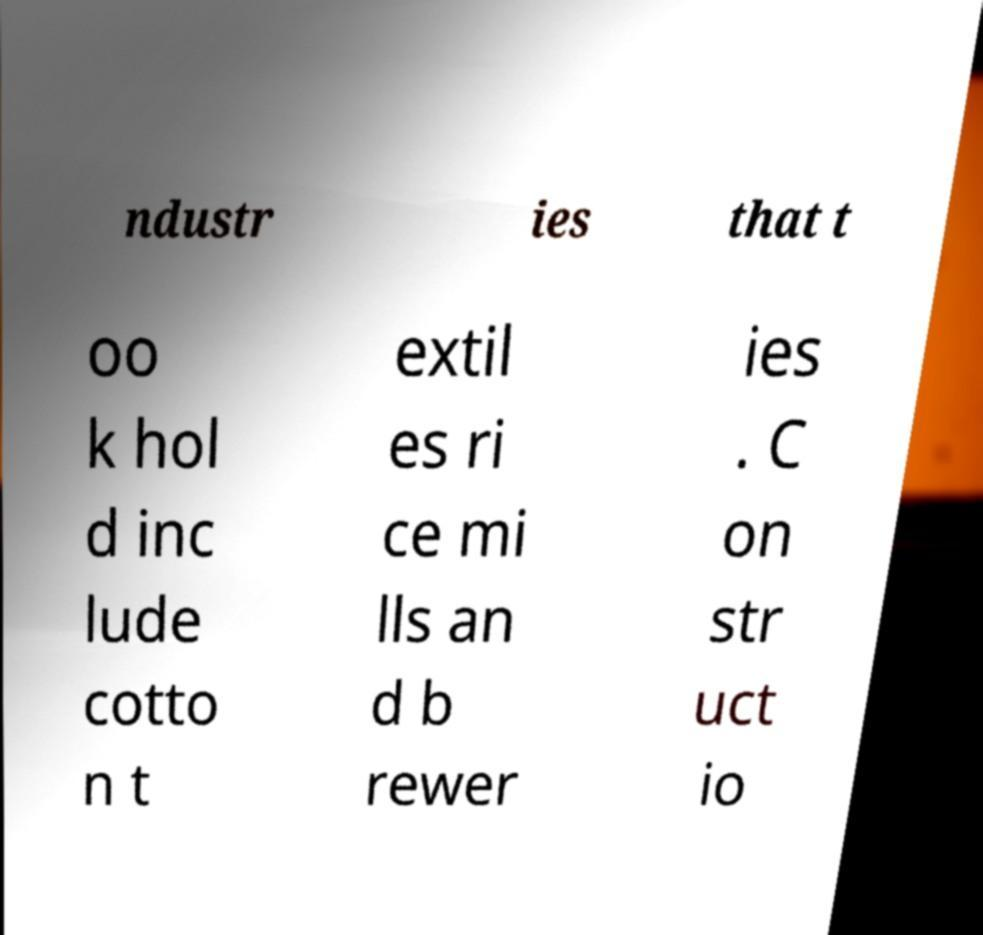Could you extract and type out the text from this image? ndustr ies that t oo k hol d inc lude cotto n t extil es ri ce mi lls an d b rewer ies . C on str uct io 